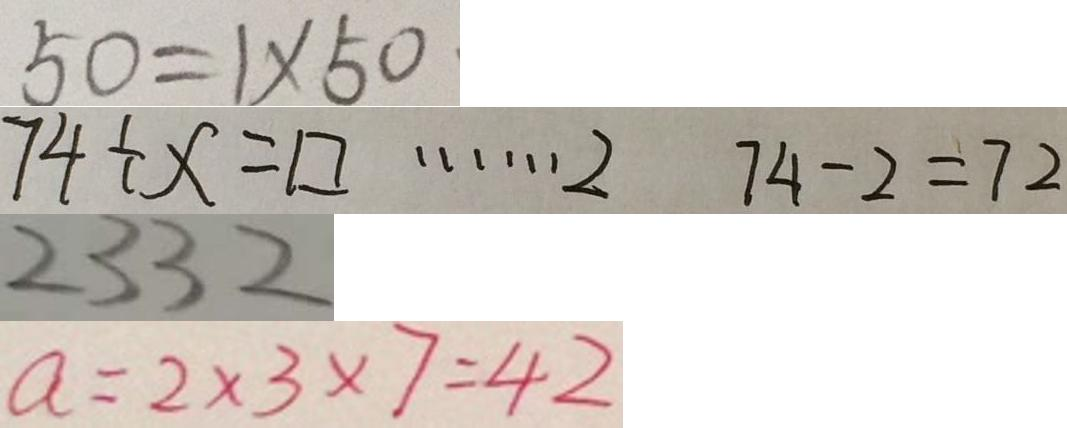Convert formula to latex. <formula><loc_0><loc_0><loc_500><loc_500>5 0 = 1 \times 5 0 
 7 4 \div x = \square \cdots 2 7 4 - 2 = 7 2 
 2 3 3 2 
 a = 2 \times 3 \times 7 = 4 2</formula> 